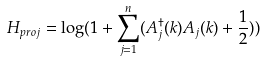<formula> <loc_0><loc_0><loc_500><loc_500>H _ { p r o j } = \log ( 1 + \sum _ { j = 1 } ^ { n } ( A _ { j } ^ { \dagger } ( k ) A _ { j } ( k ) + \frac { 1 } { 2 } ) )</formula> 